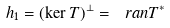<formula> <loc_0><loc_0><loc_500><loc_500>\ h _ { 1 } = ( \ker T ) ^ { \perp } = \ r a n T ^ { * }</formula> 